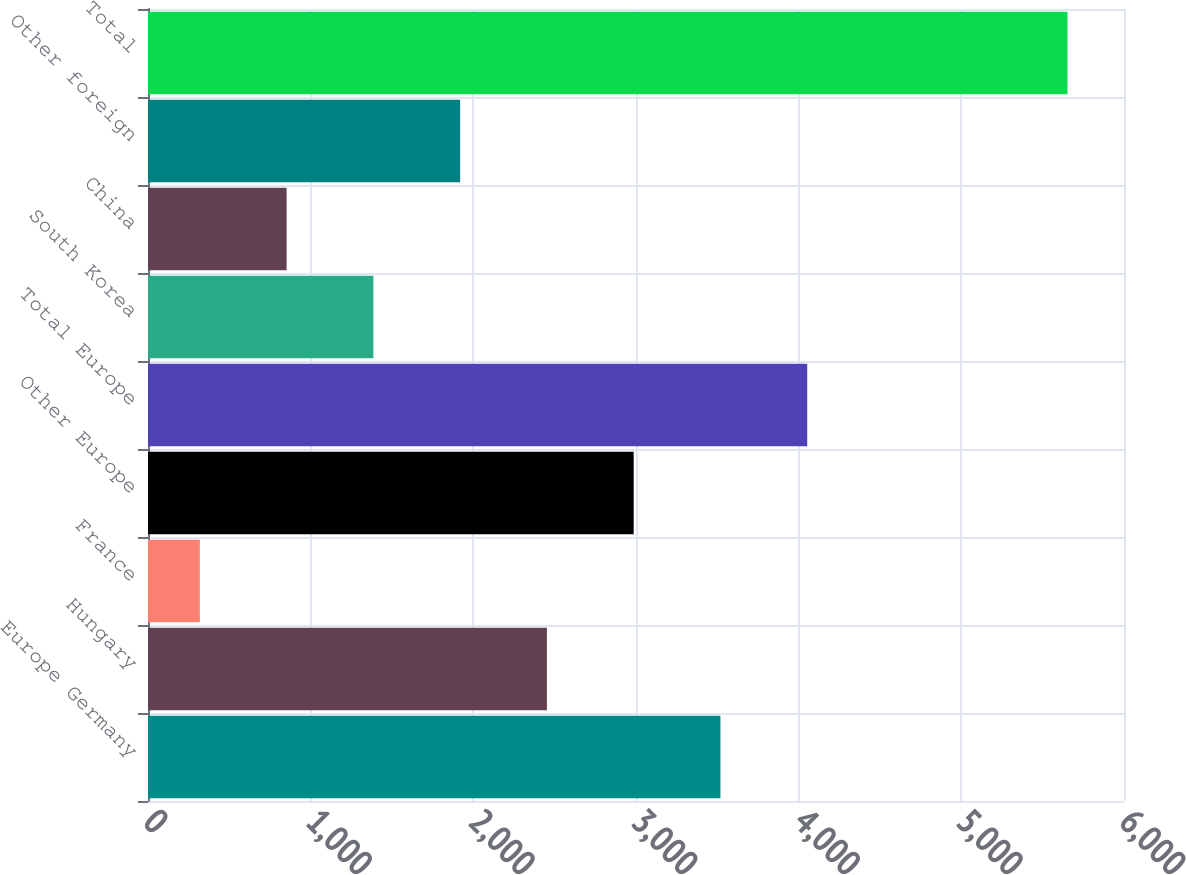Convert chart. <chart><loc_0><loc_0><loc_500><loc_500><bar_chart><fcel>Europe Germany<fcel>Hungary<fcel>France<fcel>Other Europe<fcel>Total Europe<fcel>South Korea<fcel>China<fcel>Other foreign<fcel>Total<nl><fcel>3519.16<fcel>2452.34<fcel>318.7<fcel>2985.75<fcel>4052.57<fcel>1385.52<fcel>852.11<fcel>1918.93<fcel>5652.8<nl></chart> 